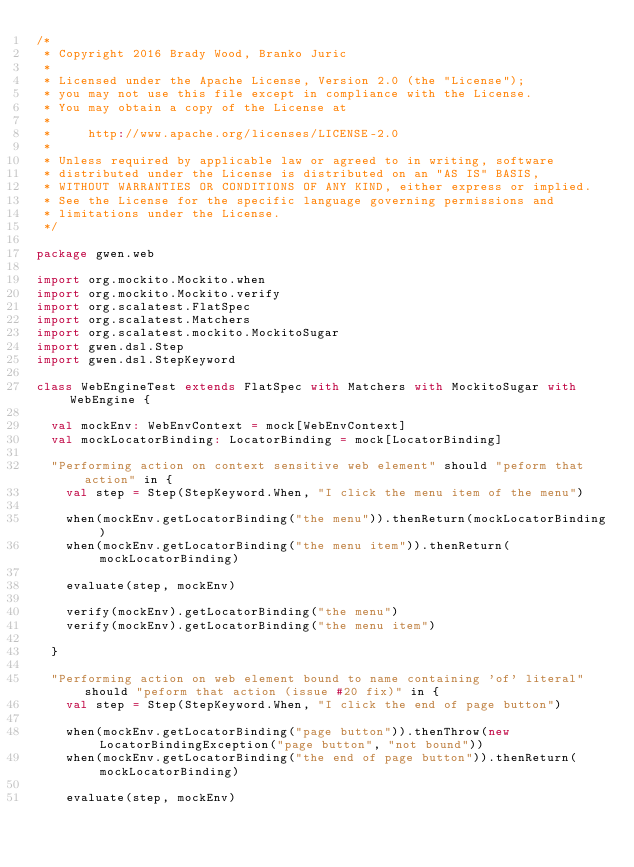Convert code to text. <code><loc_0><loc_0><loc_500><loc_500><_Scala_>/*
 * Copyright 2016 Brady Wood, Branko Juric
 * 
 * Licensed under the Apache License, Version 2.0 (the "License");
 * you may not use this file except in compliance with the License.
 * You may obtain a copy of the License at
 * 
 *     http://www.apache.org/licenses/LICENSE-2.0
 * 
 * Unless required by applicable law or agreed to in writing, software
 * distributed under the License is distributed on an "AS IS" BASIS,
 * WITHOUT WARRANTIES OR CONDITIONS OF ANY KIND, either express or implied.
 * See the License for the specific language governing permissions and
 * limitations under the License.
 */

package gwen.web

import org.mockito.Mockito.when
import org.mockito.Mockito.verify
import org.scalatest.FlatSpec
import org.scalatest.Matchers
import org.scalatest.mockito.MockitoSugar
import gwen.dsl.Step
import gwen.dsl.StepKeyword

class WebEngineTest extends FlatSpec with Matchers with MockitoSugar with WebEngine {
  
  val mockEnv: WebEnvContext = mock[WebEnvContext]
  val mockLocatorBinding: LocatorBinding = mock[LocatorBinding]
  
  "Performing action on context sensitive web element" should "peform that action" in {
    val step = Step(StepKeyword.When, "I click the menu item of the menu")
 
    when(mockEnv.getLocatorBinding("the menu")).thenReturn(mockLocatorBinding)
    when(mockEnv.getLocatorBinding("the menu item")).thenReturn(mockLocatorBinding)
    
    evaluate(step, mockEnv)
    
    verify(mockEnv).getLocatorBinding("the menu")
    verify(mockEnv).getLocatorBinding("the menu item")
        
  }
  
  "Performing action on web element bound to name containing 'of' literal" should "peform that action (issue #20 fix)" in {
    val step = Step(StepKeyword.When, "I click the end of page button")
 
    when(mockEnv.getLocatorBinding("page button")).thenThrow(new LocatorBindingException("page button", "not bound"))
    when(mockEnv.getLocatorBinding("the end of page button")).thenReturn(mockLocatorBinding)
    
    evaluate(step, mockEnv)</code> 